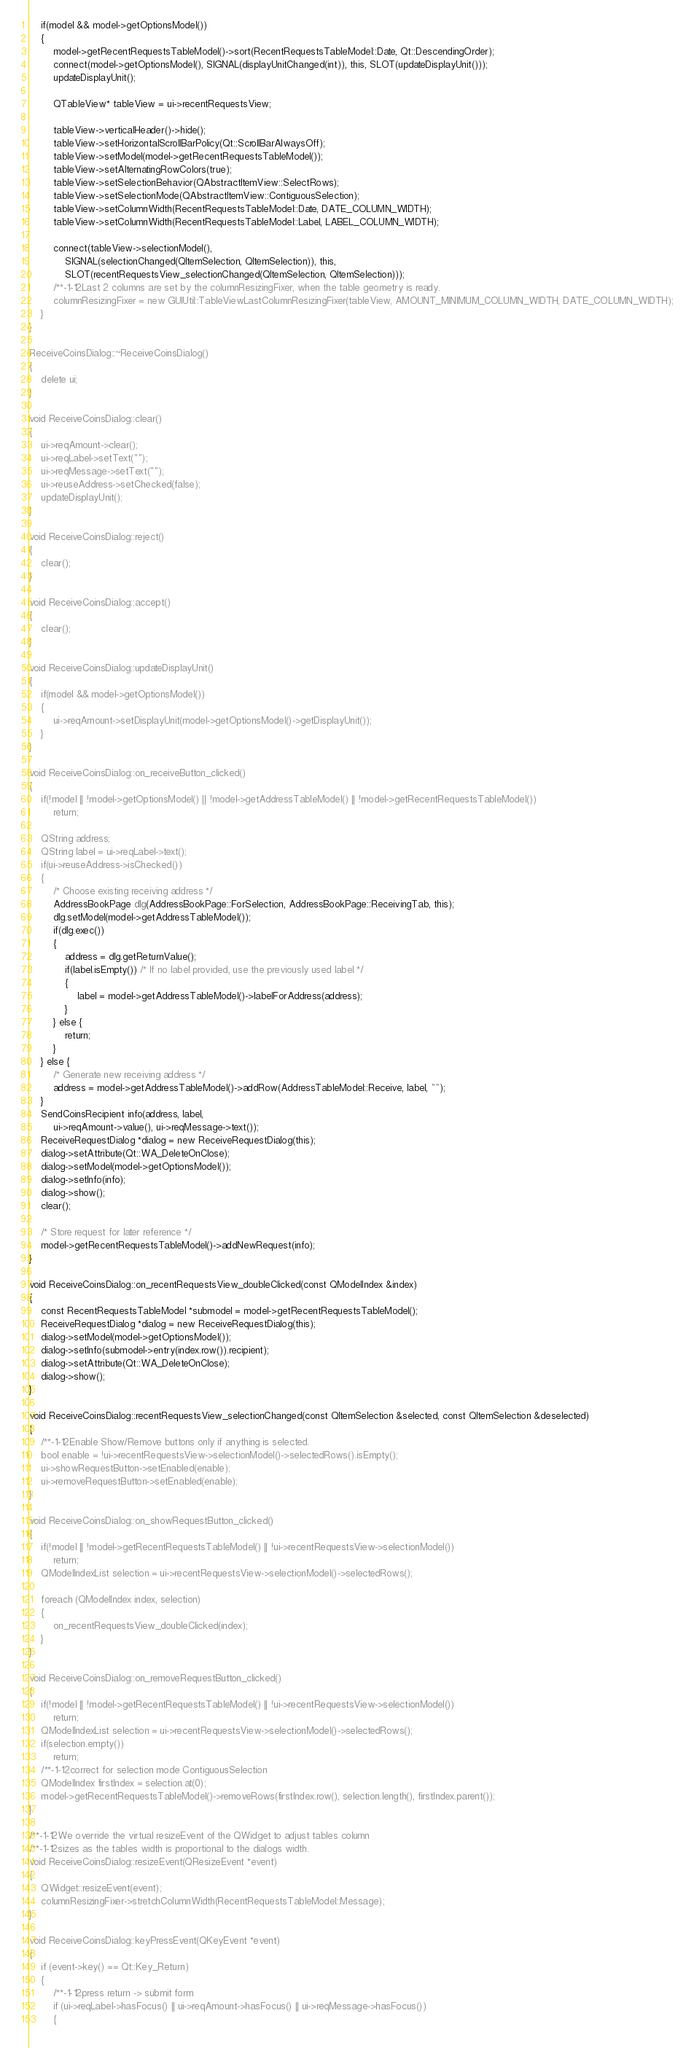<code> <loc_0><loc_0><loc_500><loc_500><_C++_>    if(model && model->getOptionsModel())
    {
        model->getRecentRequestsTableModel()->sort(RecentRequestsTableModel::Date, Qt::DescendingOrder);
        connect(model->getOptionsModel(), SIGNAL(displayUnitChanged(int)), this, SLOT(updateDisplayUnit()));
        updateDisplayUnit();

        QTableView* tableView = ui->recentRequestsView;

        tableView->verticalHeader()->hide();
        tableView->setHorizontalScrollBarPolicy(Qt::ScrollBarAlwaysOff);
        tableView->setModel(model->getRecentRequestsTableModel());
        tableView->setAlternatingRowColors(true);
        tableView->setSelectionBehavior(QAbstractItemView::SelectRows);
        tableView->setSelectionMode(QAbstractItemView::ContiguousSelection);
        tableView->setColumnWidth(RecentRequestsTableModel::Date, DATE_COLUMN_WIDTH);
        tableView->setColumnWidth(RecentRequestsTableModel::Label, LABEL_COLUMN_WIDTH);

        connect(tableView->selectionModel(),
            SIGNAL(selectionChanged(QItemSelection, QItemSelection)), this,
            SLOT(recentRequestsView_selectionChanged(QItemSelection, QItemSelection)));
        /**-1-12Last 2 columns are set by the columnResizingFixer, when the table geometry is ready.
        columnResizingFixer = new GUIUtil::TableViewLastColumnResizingFixer(tableView, AMOUNT_MINIMUM_COLUMN_WIDTH, DATE_COLUMN_WIDTH);
    }
}

ReceiveCoinsDialog::~ReceiveCoinsDialog()
{
    delete ui;
}

void ReceiveCoinsDialog::clear()
{
    ui->reqAmount->clear();
    ui->reqLabel->setText("");
    ui->reqMessage->setText("");
    ui->reuseAddress->setChecked(false);
    updateDisplayUnit();
}

void ReceiveCoinsDialog::reject()
{
    clear();
}

void ReceiveCoinsDialog::accept()
{
    clear();
}

void ReceiveCoinsDialog::updateDisplayUnit()
{
    if(model && model->getOptionsModel())
    {
        ui->reqAmount->setDisplayUnit(model->getOptionsModel()->getDisplayUnit());
    }
}

void ReceiveCoinsDialog::on_receiveButton_clicked()
{
    if(!model || !model->getOptionsModel() || !model->getAddressTableModel() || !model->getRecentRequestsTableModel())
        return;

    QString address;
    QString label = ui->reqLabel->text();
    if(ui->reuseAddress->isChecked())
    {
        /* Choose existing receiving address */
        AddressBookPage dlg(AddressBookPage::ForSelection, AddressBookPage::ReceivingTab, this);
        dlg.setModel(model->getAddressTableModel());
        if(dlg.exec())
        {
            address = dlg.getReturnValue();
            if(label.isEmpty()) /* If no label provided, use the previously used label */
            {
                label = model->getAddressTableModel()->labelForAddress(address);
            }
        } else {
            return;
        }
    } else {
        /* Generate new receiving address */
        address = model->getAddressTableModel()->addRow(AddressTableModel::Receive, label, "");
    }
    SendCoinsRecipient info(address, label,
        ui->reqAmount->value(), ui->reqMessage->text());
    ReceiveRequestDialog *dialog = new ReceiveRequestDialog(this);
    dialog->setAttribute(Qt::WA_DeleteOnClose);
    dialog->setModel(model->getOptionsModel());
    dialog->setInfo(info);
    dialog->show();
    clear();

    /* Store request for later reference */
    model->getRecentRequestsTableModel()->addNewRequest(info);
}

void ReceiveCoinsDialog::on_recentRequestsView_doubleClicked(const QModelIndex &index)
{
    const RecentRequestsTableModel *submodel = model->getRecentRequestsTableModel();
    ReceiveRequestDialog *dialog = new ReceiveRequestDialog(this);
    dialog->setModel(model->getOptionsModel());
    dialog->setInfo(submodel->entry(index.row()).recipient);
    dialog->setAttribute(Qt::WA_DeleteOnClose);
    dialog->show();
}

void ReceiveCoinsDialog::recentRequestsView_selectionChanged(const QItemSelection &selected, const QItemSelection &deselected)
{
    /**-1-12Enable Show/Remove buttons only if anything is selected.
    bool enable = !ui->recentRequestsView->selectionModel()->selectedRows().isEmpty();
    ui->showRequestButton->setEnabled(enable);
    ui->removeRequestButton->setEnabled(enable);
}

void ReceiveCoinsDialog::on_showRequestButton_clicked()
{
    if(!model || !model->getRecentRequestsTableModel() || !ui->recentRequestsView->selectionModel())
        return;
    QModelIndexList selection = ui->recentRequestsView->selectionModel()->selectedRows();

    foreach (QModelIndex index, selection)
    {
        on_recentRequestsView_doubleClicked(index);
    }
}

void ReceiveCoinsDialog::on_removeRequestButton_clicked()
{
    if(!model || !model->getRecentRequestsTableModel() || !ui->recentRequestsView->selectionModel())
        return;
    QModelIndexList selection = ui->recentRequestsView->selectionModel()->selectedRows();
    if(selection.empty())
        return;
    /**-1-12correct for selection mode ContiguousSelection
    QModelIndex firstIndex = selection.at(0);
    model->getRecentRequestsTableModel()->removeRows(firstIndex.row(), selection.length(), firstIndex.parent());
}

/**-1-12We override the virtual resizeEvent of the QWidget to adjust tables column
/**-1-12sizes as the tables width is proportional to the dialogs width.
void ReceiveCoinsDialog::resizeEvent(QResizeEvent *event)
{
    QWidget::resizeEvent(event);
    columnResizingFixer->stretchColumnWidth(RecentRequestsTableModel::Message);
}

void ReceiveCoinsDialog::keyPressEvent(QKeyEvent *event)
{
    if (event->key() == Qt::Key_Return)
    {
        /**-1-12press return -> submit form
        if (ui->reqLabel->hasFocus() || ui->reqAmount->hasFocus() || ui->reqMessage->hasFocus())
        {</code> 